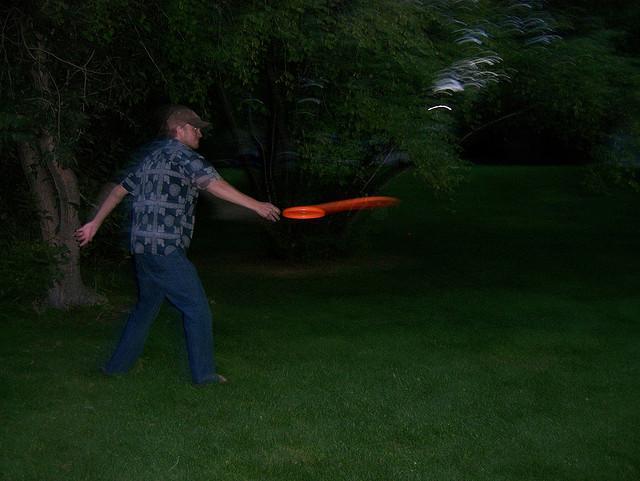How many leather couches are there in the living room?
Give a very brief answer. 0. 